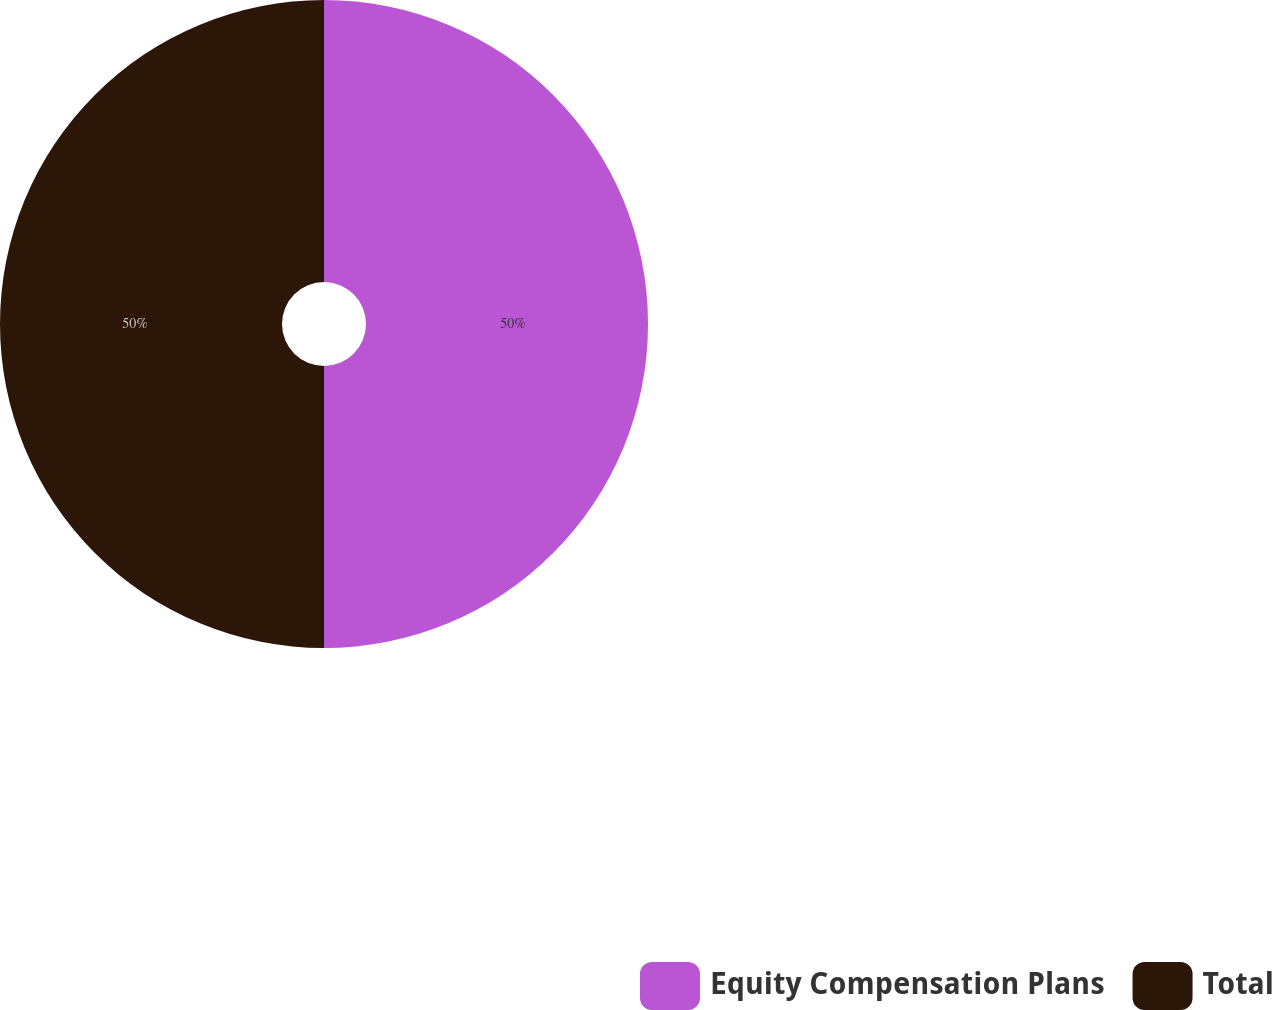Convert chart to OTSL. <chart><loc_0><loc_0><loc_500><loc_500><pie_chart><fcel>Equity Compensation Plans<fcel>Total<nl><fcel>50.0%<fcel>50.0%<nl></chart> 